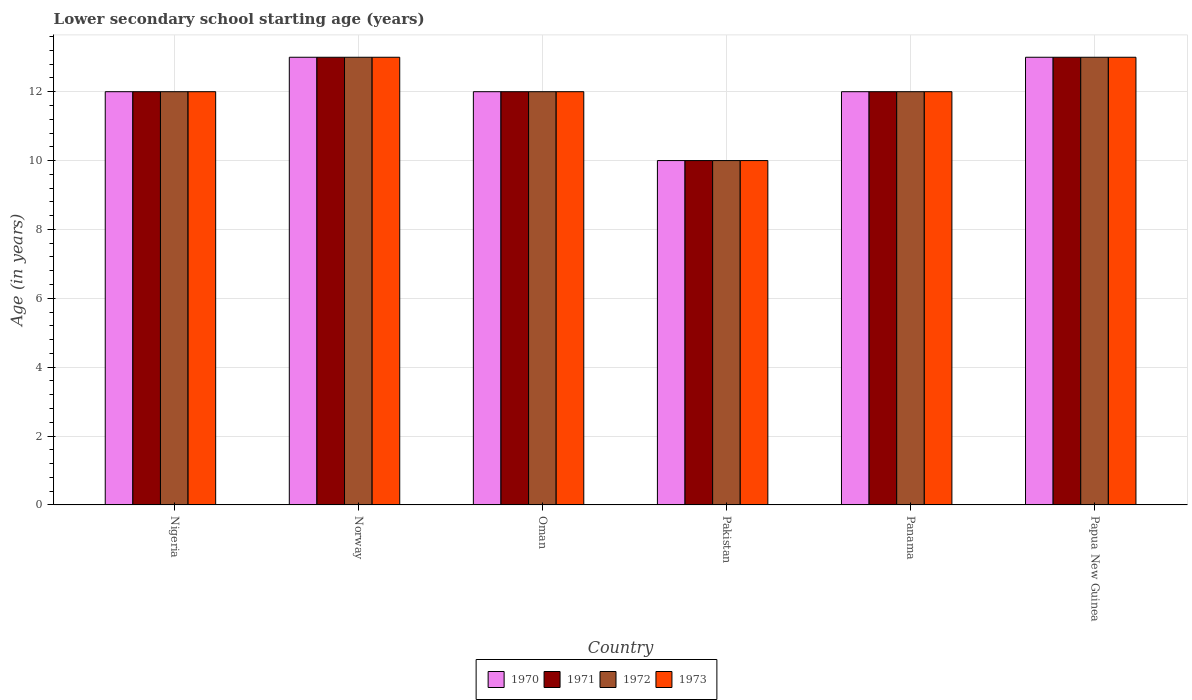How many bars are there on the 2nd tick from the right?
Ensure brevity in your answer.  4. Across all countries, what is the minimum lower secondary school starting age of children in 1972?
Your answer should be compact. 10. In which country was the lower secondary school starting age of children in 1973 minimum?
Your response must be concise. Pakistan. What is the difference between the lower secondary school starting age of children in 1973 in Nigeria and that in Norway?
Provide a short and direct response. -1. What is the average lower secondary school starting age of children in 1973 per country?
Provide a short and direct response. 12. Is the difference between the lower secondary school starting age of children in 1972 in Nigeria and Panama greater than the difference between the lower secondary school starting age of children in 1973 in Nigeria and Panama?
Offer a terse response. No. In how many countries, is the lower secondary school starting age of children in 1970 greater than the average lower secondary school starting age of children in 1970 taken over all countries?
Your answer should be very brief. 2. What does the 1st bar from the right in Panama represents?
Give a very brief answer. 1973. Are all the bars in the graph horizontal?
Your answer should be very brief. No. What is the difference between two consecutive major ticks on the Y-axis?
Offer a very short reply. 2. Does the graph contain any zero values?
Your response must be concise. No. Does the graph contain grids?
Your answer should be very brief. Yes. Where does the legend appear in the graph?
Make the answer very short. Bottom center. How are the legend labels stacked?
Provide a succinct answer. Horizontal. What is the title of the graph?
Give a very brief answer. Lower secondary school starting age (years). What is the label or title of the Y-axis?
Offer a terse response. Age (in years). What is the Age (in years) of 1972 in Nigeria?
Your response must be concise. 12. What is the Age (in years) in 1973 in Nigeria?
Offer a terse response. 12. What is the Age (in years) of 1971 in Norway?
Offer a very short reply. 13. What is the Age (in years) of 1972 in Norway?
Ensure brevity in your answer.  13. What is the Age (in years) in 1970 in Oman?
Ensure brevity in your answer.  12. What is the Age (in years) of 1973 in Oman?
Offer a terse response. 12. What is the Age (in years) of 1970 in Pakistan?
Provide a succinct answer. 10. What is the Age (in years) in 1971 in Pakistan?
Provide a short and direct response. 10. What is the Age (in years) of 1972 in Pakistan?
Your answer should be compact. 10. What is the Age (in years) of 1973 in Pakistan?
Ensure brevity in your answer.  10. What is the Age (in years) of 1970 in Panama?
Your answer should be compact. 12. What is the Age (in years) of 1971 in Panama?
Give a very brief answer. 12. What is the Age (in years) in 1972 in Panama?
Give a very brief answer. 12. What is the Age (in years) of 1973 in Panama?
Your response must be concise. 12. What is the Age (in years) in 1970 in Papua New Guinea?
Your answer should be compact. 13. What is the Age (in years) in 1972 in Papua New Guinea?
Provide a succinct answer. 13. Across all countries, what is the maximum Age (in years) in 1970?
Offer a very short reply. 13. What is the total Age (in years) of 1970 in the graph?
Your response must be concise. 72. What is the total Age (in years) in 1971 in the graph?
Provide a succinct answer. 72. What is the total Age (in years) of 1972 in the graph?
Your response must be concise. 72. What is the total Age (in years) of 1973 in the graph?
Offer a terse response. 72. What is the difference between the Age (in years) of 1970 in Nigeria and that in Norway?
Keep it short and to the point. -1. What is the difference between the Age (in years) in 1973 in Nigeria and that in Norway?
Offer a very short reply. -1. What is the difference between the Age (in years) of 1971 in Nigeria and that in Oman?
Offer a terse response. 0. What is the difference between the Age (in years) in 1970 in Nigeria and that in Pakistan?
Provide a succinct answer. 2. What is the difference between the Age (in years) in 1971 in Nigeria and that in Pakistan?
Make the answer very short. 2. What is the difference between the Age (in years) of 1973 in Nigeria and that in Pakistan?
Provide a succinct answer. 2. What is the difference between the Age (in years) in 1970 in Nigeria and that in Panama?
Provide a short and direct response. 0. What is the difference between the Age (in years) of 1971 in Nigeria and that in Panama?
Give a very brief answer. 0. What is the difference between the Age (in years) of 1972 in Nigeria and that in Panama?
Ensure brevity in your answer.  0. What is the difference between the Age (in years) of 1970 in Nigeria and that in Papua New Guinea?
Offer a very short reply. -1. What is the difference between the Age (in years) of 1972 in Nigeria and that in Papua New Guinea?
Your response must be concise. -1. What is the difference between the Age (in years) of 1973 in Nigeria and that in Papua New Guinea?
Keep it short and to the point. -1. What is the difference between the Age (in years) in 1970 in Norway and that in Oman?
Your answer should be compact. 1. What is the difference between the Age (in years) of 1971 in Norway and that in Oman?
Give a very brief answer. 1. What is the difference between the Age (in years) in 1972 in Norway and that in Oman?
Your answer should be compact. 1. What is the difference between the Age (in years) of 1970 in Norway and that in Pakistan?
Your answer should be compact. 3. What is the difference between the Age (in years) in 1973 in Norway and that in Pakistan?
Offer a very short reply. 3. What is the difference between the Age (in years) of 1970 in Norway and that in Panama?
Offer a very short reply. 1. What is the difference between the Age (in years) in 1971 in Norway and that in Panama?
Provide a succinct answer. 1. What is the difference between the Age (in years) in 1972 in Norway and that in Papua New Guinea?
Offer a terse response. 0. What is the difference between the Age (in years) of 1970 in Oman and that in Pakistan?
Your answer should be very brief. 2. What is the difference between the Age (in years) in 1972 in Oman and that in Pakistan?
Provide a short and direct response. 2. What is the difference between the Age (in years) in 1973 in Oman and that in Panama?
Give a very brief answer. 0. What is the difference between the Age (in years) in 1970 in Oman and that in Papua New Guinea?
Make the answer very short. -1. What is the difference between the Age (in years) of 1973 in Oman and that in Papua New Guinea?
Keep it short and to the point. -1. What is the difference between the Age (in years) of 1970 in Pakistan and that in Panama?
Keep it short and to the point. -2. What is the difference between the Age (in years) in 1972 in Pakistan and that in Panama?
Keep it short and to the point. -2. What is the difference between the Age (in years) of 1973 in Pakistan and that in Panama?
Ensure brevity in your answer.  -2. What is the difference between the Age (in years) of 1970 in Pakistan and that in Papua New Guinea?
Your answer should be compact. -3. What is the difference between the Age (in years) in 1971 in Pakistan and that in Papua New Guinea?
Make the answer very short. -3. What is the difference between the Age (in years) in 1972 in Pakistan and that in Papua New Guinea?
Your response must be concise. -3. What is the difference between the Age (in years) in 1973 in Pakistan and that in Papua New Guinea?
Offer a terse response. -3. What is the difference between the Age (in years) in 1970 in Panama and that in Papua New Guinea?
Offer a terse response. -1. What is the difference between the Age (in years) of 1971 in Panama and that in Papua New Guinea?
Offer a very short reply. -1. What is the difference between the Age (in years) of 1972 in Panama and that in Papua New Guinea?
Your answer should be compact. -1. What is the difference between the Age (in years) in 1970 in Nigeria and the Age (in years) in 1973 in Norway?
Your response must be concise. -1. What is the difference between the Age (in years) in 1971 in Nigeria and the Age (in years) in 1973 in Norway?
Provide a short and direct response. -1. What is the difference between the Age (in years) of 1972 in Nigeria and the Age (in years) of 1973 in Norway?
Offer a very short reply. -1. What is the difference between the Age (in years) in 1970 in Nigeria and the Age (in years) in 1973 in Oman?
Keep it short and to the point. 0. What is the difference between the Age (in years) in 1971 in Nigeria and the Age (in years) in 1972 in Oman?
Keep it short and to the point. 0. What is the difference between the Age (in years) in 1971 in Nigeria and the Age (in years) in 1973 in Oman?
Make the answer very short. 0. What is the difference between the Age (in years) of 1970 in Nigeria and the Age (in years) of 1971 in Pakistan?
Your answer should be very brief. 2. What is the difference between the Age (in years) in 1970 in Nigeria and the Age (in years) in 1972 in Pakistan?
Offer a very short reply. 2. What is the difference between the Age (in years) in 1970 in Nigeria and the Age (in years) in 1973 in Pakistan?
Your answer should be compact. 2. What is the difference between the Age (in years) of 1971 in Nigeria and the Age (in years) of 1972 in Pakistan?
Provide a succinct answer. 2. What is the difference between the Age (in years) in 1971 in Nigeria and the Age (in years) in 1973 in Pakistan?
Offer a very short reply. 2. What is the difference between the Age (in years) of 1972 in Nigeria and the Age (in years) of 1973 in Pakistan?
Keep it short and to the point. 2. What is the difference between the Age (in years) of 1970 in Nigeria and the Age (in years) of 1972 in Panama?
Your response must be concise. 0. What is the difference between the Age (in years) in 1970 in Nigeria and the Age (in years) in 1973 in Panama?
Make the answer very short. 0. What is the difference between the Age (in years) of 1971 in Nigeria and the Age (in years) of 1973 in Panama?
Keep it short and to the point. 0. What is the difference between the Age (in years) of 1972 in Nigeria and the Age (in years) of 1973 in Panama?
Give a very brief answer. 0. What is the difference between the Age (in years) in 1970 in Nigeria and the Age (in years) in 1973 in Papua New Guinea?
Ensure brevity in your answer.  -1. What is the difference between the Age (in years) of 1971 in Nigeria and the Age (in years) of 1973 in Papua New Guinea?
Your answer should be compact. -1. What is the difference between the Age (in years) of 1972 in Nigeria and the Age (in years) of 1973 in Papua New Guinea?
Offer a terse response. -1. What is the difference between the Age (in years) in 1970 in Norway and the Age (in years) in 1972 in Oman?
Provide a succinct answer. 1. What is the difference between the Age (in years) of 1971 in Norway and the Age (in years) of 1972 in Oman?
Provide a short and direct response. 1. What is the difference between the Age (in years) in 1971 in Norway and the Age (in years) in 1973 in Oman?
Ensure brevity in your answer.  1. What is the difference between the Age (in years) in 1970 in Norway and the Age (in years) in 1971 in Pakistan?
Make the answer very short. 3. What is the difference between the Age (in years) in 1970 in Norway and the Age (in years) in 1973 in Pakistan?
Provide a succinct answer. 3. What is the difference between the Age (in years) in 1971 in Norway and the Age (in years) in 1972 in Pakistan?
Your answer should be compact. 3. What is the difference between the Age (in years) in 1970 in Norway and the Age (in years) in 1973 in Panama?
Make the answer very short. 1. What is the difference between the Age (in years) in 1971 in Norway and the Age (in years) in 1972 in Panama?
Offer a very short reply. 1. What is the difference between the Age (in years) in 1971 in Norway and the Age (in years) in 1973 in Panama?
Provide a succinct answer. 1. What is the difference between the Age (in years) in 1972 in Norway and the Age (in years) in 1973 in Panama?
Your answer should be compact. 1. What is the difference between the Age (in years) of 1970 in Norway and the Age (in years) of 1973 in Papua New Guinea?
Your response must be concise. 0. What is the difference between the Age (in years) of 1971 in Norway and the Age (in years) of 1972 in Papua New Guinea?
Provide a short and direct response. 0. What is the difference between the Age (in years) of 1972 in Norway and the Age (in years) of 1973 in Papua New Guinea?
Your answer should be compact. 0. What is the difference between the Age (in years) in 1971 in Oman and the Age (in years) in 1973 in Pakistan?
Provide a succinct answer. 2. What is the difference between the Age (in years) in 1970 in Oman and the Age (in years) in 1973 in Panama?
Your answer should be very brief. 0. What is the difference between the Age (in years) in 1970 in Oman and the Age (in years) in 1971 in Papua New Guinea?
Make the answer very short. -1. What is the difference between the Age (in years) in 1971 in Oman and the Age (in years) in 1972 in Papua New Guinea?
Make the answer very short. -1. What is the difference between the Age (in years) in 1970 in Pakistan and the Age (in years) in 1972 in Panama?
Your answer should be compact. -2. What is the difference between the Age (in years) in 1971 in Pakistan and the Age (in years) in 1973 in Panama?
Offer a terse response. -2. What is the difference between the Age (in years) of 1972 in Pakistan and the Age (in years) of 1973 in Panama?
Offer a terse response. -2. What is the difference between the Age (in years) of 1970 in Pakistan and the Age (in years) of 1972 in Papua New Guinea?
Provide a succinct answer. -3. What is the difference between the Age (in years) in 1971 in Pakistan and the Age (in years) in 1973 in Papua New Guinea?
Your answer should be very brief. -3. What is the difference between the Age (in years) in 1972 in Pakistan and the Age (in years) in 1973 in Papua New Guinea?
Your answer should be very brief. -3. What is the difference between the Age (in years) in 1971 in Panama and the Age (in years) in 1972 in Papua New Guinea?
Provide a succinct answer. -1. What is the difference between the Age (in years) in 1971 in Panama and the Age (in years) in 1973 in Papua New Guinea?
Offer a very short reply. -1. What is the difference between the Age (in years) in 1972 in Panama and the Age (in years) in 1973 in Papua New Guinea?
Make the answer very short. -1. What is the average Age (in years) in 1970 per country?
Offer a terse response. 12. What is the average Age (in years) in 1972 per country?
Offer a terse response. 12. What is the difference between the Age (in years) of 1970 and Age (in years) of 1971 in Nigeria?
Ensure brevity in your answer.  0. What is the difference between the Age (in years) in 1970 and Age (in years) in 1972 in Nigeria?
Offer a terse response. 0. What is the difference between the Age (in years) in 1971 and Age (in years) in 1972 in Nigeria?
Offer a very short reply. 0. What is the difference between the Age (in years) in 1970 and Age (in years) in 1972 in Norway?
Make the answer very short. 0. What is the difference between the Age (in years) in 1970 and Age (in years) in 1973 in Norway?
Provide a succinct answer. 0. What is the difference between the Age (in years) of 1971 and Age (in years) of 1972 in Norway?
Keep it short and to the point. 0. What is the difference between the Age (in years) of 1971 and Age (in years) of 1973 in Norway?
Provide a succinct answer. 0. What is the difference between the Age (in years) in 1972 and Age (in years) in 1973 in Norway?
Ensure brevity in your answer.  0. What is the difference between the Age (in years) of 1970 and Age (in years) of 1972 in Oman?
Your answer should be compact. 0. What is the difference between the Age (in years) of 1970 and Age (in years) of 1973 in Oman?
Keep it short and to the point. 0. What is the difference between the Age (in years) in 1971 and Age (in years) in 1972 in Oman?
Your answer should be compact. 0. What is the difference between the Age (in years) in 1971 and Age (in years) in 1973 in Oman?
Make the answer very short. 0. What is the difference between the Age (in years) of 1970 and Age (in years) of 1972 in Pakistan?
Offer a very short reply. 0. What is the difference between the Age (in years) of 1971 and Age (in years) of 1972 in Pakistan?
Your answer should be very brief. 0. What is the difference between the Age (in years) in 1971 and Age (in years) in 1973 in Pakistan?
Keep it short and to the point. 0. What is the difference between the Age (in years) of 1970 and Age (in years) of 1972 in Panama?
Make the answer very short. 0. What is the difference between the Age (in years) in 1972 and Age (in years) in 1973 in Panama?
Your answer should be compact. 0. What is the difference between the Age (in years) of 1970 and Age (in years) of 1973 in Papua New Guinea?
Your response must be concise. 0. What is the difference between the Age (in years) in 1971 and Age (in years) in 1972 in Papua New Guinea?
Keep it short and to the point. 0. What is the ratio of the Age (in years) of 1970 in Nigeria to that in Norway?
Ensure brevity in your answer.  0.92. What is the ratio of the Age (in years) in 1972 in Nigeria to that in Norway?
Make the answer very short. 0.92. What is the ratio of the Age (in years) of 1973 in Nigeria to that in Norway?
Provide a short and direct response. 0.92. What is the ratio of the Age (in years) of 1971 in Nigeria to that in Oman?
Keep it short and to the point. 1. What is the ratio of the Age (in years) of 1973 in Nigeria to that in Oman?
Provide a short and direct response. 1. What is the ratio of the Age (in years) of 1971 in Nigeria to that in Pakistan?
Your response must be concise. 1.2. What is the ratio of the Age (in years) in 1970 in Nigeria to that in Panama?
Offer a very short reply. 1. What is the ratio of the Age (in years) in 1971 in Nigeria to that in Panama?
Provide a short and direct response. 1. What is the ratio of the Age (in years) in 1972 in Nigeria to that in Panama?
Ensure brevity in your answer.  1. What is the ratio of the Age (in years) in 1970 in Nigeria to that in Papua New Guinea?
Give a very brief answer. 0.92. What is the ratio of the Age (in years) of 1971 in Nigeria to that in Papua New Guinea?
Your answer should be compact. 0.92. What is the ratio of the Age (in years) in 1971 in Norway to that in Oman?
Your answer should be compact. 1.08. What is the ratio of the Age (in years) of 1972 in Norway to that in Oman?
Your answer should be compact. 1.08. What is the ratio of the Age (in years) in 1970 in Norway to that in Pakistan?
Keep it short and to the point. 1.3. What is the ratio of the Age (in years) of 1972 in Norway to that in Panama?
Provide a short and direct response. 1.08. What is the ratio of the Age (in years) of 1970 in Norway to that in Papua New Guinea?
Your response must be concise. 1. What is the ratio of the Age (in years) in 1971 in Norway to that in Papua New Guinea?
Give a very brief answer. 1. What is the ratio of the Age (in years) in 1970 in Oman to that in Pakistan?
Offer a very short reply. 1.2. What is the ratio of the Age (in years) of 1971 in Oman to that in Pakistan?
Keep it short and to the point. 1.2. What is the ratio of the Age (in years) in 1972 in Oman to that in Pakistan?
Your answer should be very brief. 1.2. What is the ratio of the Age (in years) of 1973 in Oman to that in Pakistan?
Offer a very short reply. 1.2. What is the ratio of the Age (in years) in 1972 in Oman to that in Panama?
Give a very brief answer. 1. What is the ratio of the Age (in years) of 1973 in Oman to that in Panama?
Provide a short and direct response. 1. What is the ratio of the Age (in years) of 1970 in Pakistan to that in Panama?
Give a very brief answer. 0.83. What is the ratio of the Age (in years) of 1971 in Pakistan to that in Panama?
Provide a succinct answer. 0.83. What is the ratio of the Age (in years) in 1973 in Pakistan to that in Panama?
Provide a short and direct response. 0.83. What is the ratio of the Age (in years) in 1970 in Pakistan to that in Papua New Guinea?
Your response must be concise. 0.77. What is the ratio of the Age (in years) in 1971 in Pakistan to that in Papua New Guinea?
Provide a short and direct response. 0.77. What is the ratio of the Age (in years) in 1972 in Pakistan to that in Papua New Guinea?
Provide a short and direct response. 0.77. What is the ratio of the Age (in years) of 1973 in Pakistan to that in Papua New Guinea?
Your response must be concise. 0.77. What is the ratio of the Age (in years) in 1970 in Panama to that in Papua New Guinea?
Give a very brief answer. 0.92. What is the ratio of the Age (in years) of 1971 in Panama to that in Papua New Guinea?
Make the answer very short. 0.92. What is the ratio of the Age (in years) of 1972 in Panama to that in Papua New Guinea?
Offer a terse response. 0.92. What is the difference between the highest and the second highest Age (in years) of 1970?
Offer a very short reply. 0. What is the difference between the highest and the second highest Age (in years) in 1971?
Your answer should be very brief. 0. What is the difference between the highest and the second highest Age (in years) of 1972?
Offer a terse response. 0. What is the difference between the highest and the second highest Age (in years) in 1973?
Keep it short and to the point. 0. What is the difference between the highest and the lowest Age (in years) of 1970?
Your answer should be very brief. 3. What is the difference between the highest and the lowest Age (in years) in 1972?
Make the answer very short. 3. 